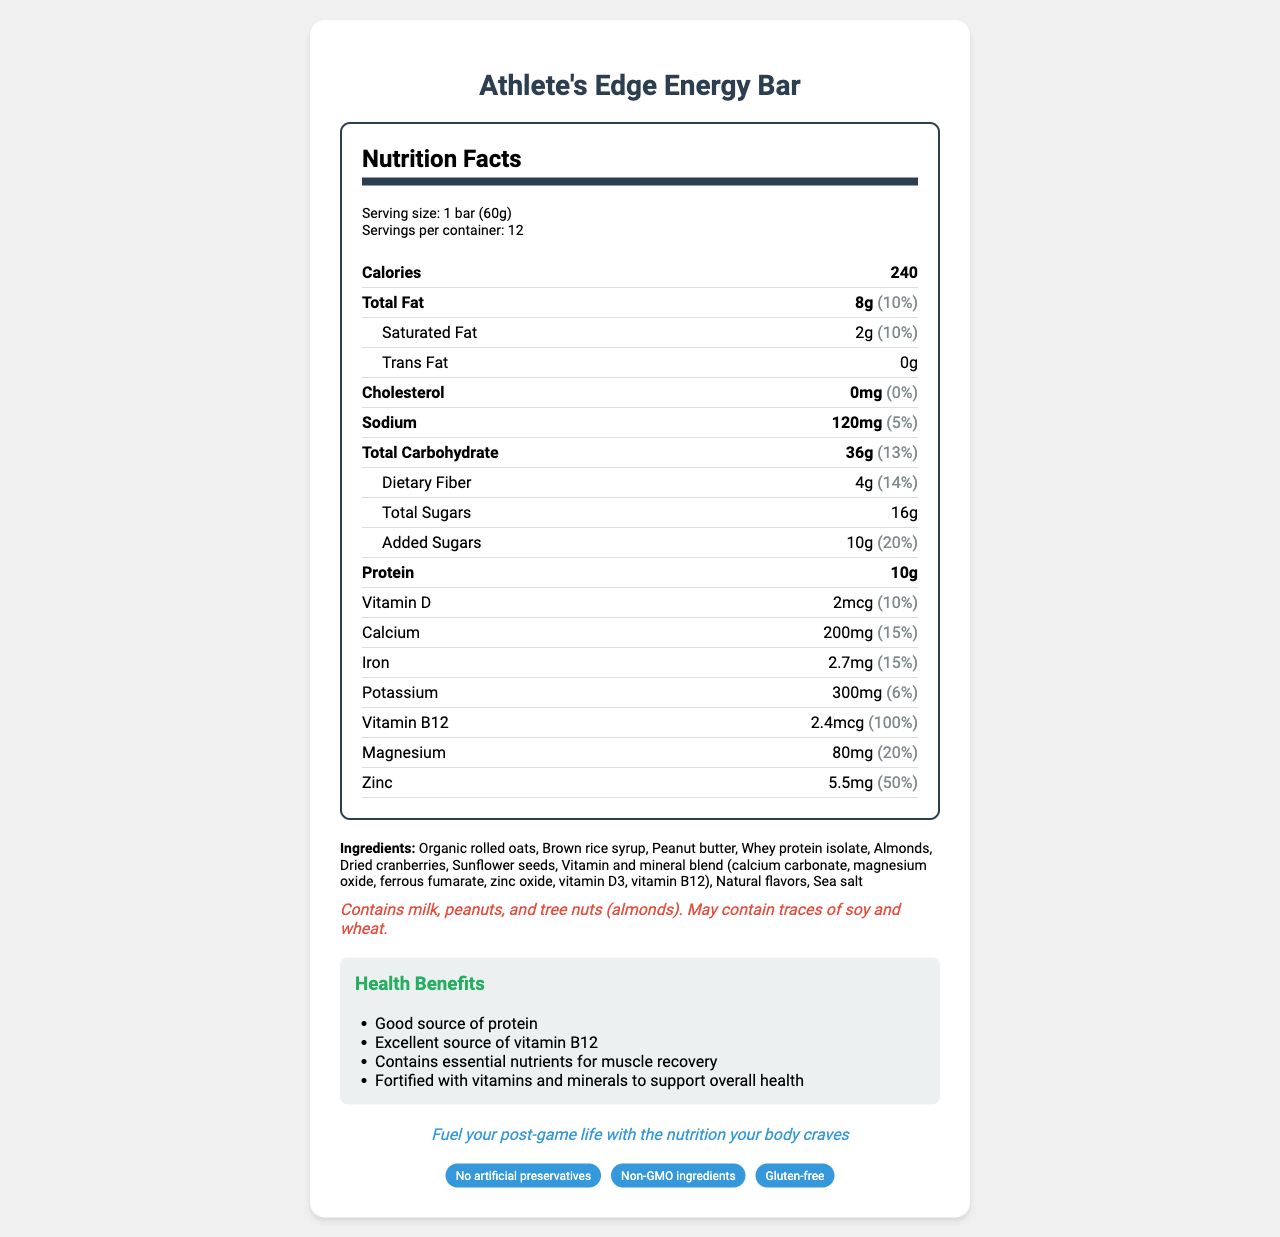what is the serving size of Athlete's Edge Energy Bar? The document lists the serving size as 1 bar weighing 60 grams.
Answer: 1 bar (60g) how many servings are there per container? The document states that there are 12 servings per container.
Answer: 12 how many calories are in one serving of the energy bar? The document specifies that each serving contains 240 calories.
Answer: 240 what is the amount of protein in one serving? The document lists the protein content per serving as 10 grams.
Answer: 10g list three ingredients found in Athlete's Edge Energy Bar The document includes a list of ingredients, and the first three are Organic rolled oats, Brown rice syrup, and Peanut butter.
Answer: Organic rolled oats, Brown rice syrup, Peanut butter what percentage of the daily value of vitamin B12 is provided by one serving? The document states that each serving provides 100% of the daily value for vitamin B12.
Answer: 100% how much sodium does the energy bar contain per serving? A. 100mg B. 120mg C. 150mg The document specifies that the sodium content per serving is 120 mg.
Answer: B. 120mg which of the following allergens are present in Athlete's Edge Energy Bar? i. milk ii. soy iii. wheat iv. peanuts A. i and ii B. i, iii, and iv C. i, ii, iii, and iv The document lists milk, peanuts, and tree nuts (almonds) under the allergen information and mentions possible traces of soy and wheat, which confirms ii and iii.
Answer: B. i, iii, and iv is the energy bar gluten-free? The document includes "Gluten-free" under the special features section.
Answer: Yes does the energy bar contain artificial preservatives? The document mentions "No artificial preservatives" as one of its special features.
Answer: No summarize the main idea of the document The document provides detailed nutritional information about the Athlete's Edge Energy Bar, highlighting its protein content, vitamin and mineral fortification, allergen information, and special features aimed at fitness-conscious consumers.
Answer: The Athlete's Edge Energy Bar is a vitamin-fortified snack designed for former professional athletes and active adults. Each serving provides 240 calories, 10 grams of protein, and various essential vitamins and minerals, including 100% of the daily value for vitamin B12. The bar is marketed as gluten-free and free from artificial preservatives. It contains organic ingredients and allergens such as milk, peanuts, and tree nuts. what is the primary target audience for Athlete's Edge Energy Bar? The document explicitly states the target audience as being former professional athletes and active adults.
Answer: Former professional athletes and active adults what is the amount of dietary fiber in one serving? A. 4g B. 6g C. 8g The document lists the dietary fiber content per serving as 4 grams.
Answer: A. 4g how much potassium is provided in one serving? The document states that each serving contains 300 mg of potassium.
Answer: 300mg how many grams of total sugars are in one serving? The document specifies that the total sugars content per serving is 16 grams.
Answer: 16g does the energy bar contain any iron? The document specifies that the energy bar contains 2.7mg of iron, which is 15% of the daily value.
Answer: Yes is the product non-GMO? The document states "Non-GMO ingredients" under special features.
Answer: Yes what is the recommended daily value percentage of saturated fat in the energy bar? The document lists the percentage of the daily value for saturated fat as 10%.
Answer: 10% what types of nuts are present in the energy bar? The document lists both peanuts and almonds in the allergen information section.
Answer: Peanuts and almonds how many calories would you consume if you eat two energy bars? Since one serving (one bar) contains 240 calories, consuming two bars would double the amount to 480 calories.
Answer: 480 calories 